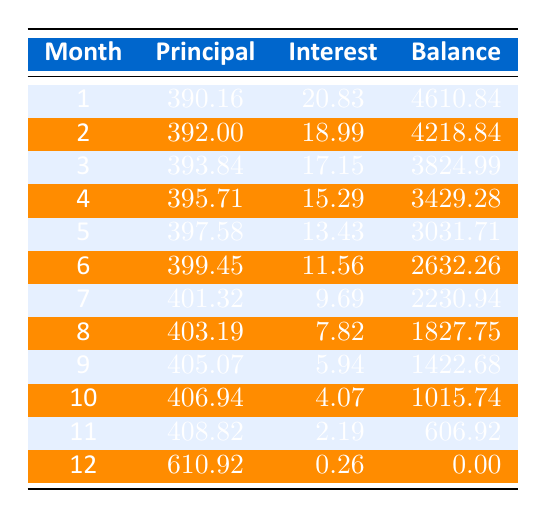What is the total loan amount? The total loan amount is specified at the beginning of the schedule as 5000.
Answer: 5000 How much was the monthly payment? The monthly payment is given in the table as 427.16.
Answer: 427.16 In which month did I pay the least interest? The interest payments are listed for each month. The lowest interest payment is 0.26, which occurs in month 12.
Answer: Month 12 What is the principal payment in month 5? The principal payment for month 5 is specifically stated in the schedule as 397.58.
Answer: 397.58 How much total principal did I pay by month 6? Adding the principal payments from months 1 to 6 gives: 390.16 + 392.00 + 393.84 + 395.71 + 397.58 + 399.45 = 2268.74.
Answer: 2268.74 Is the remaining balance after month 3 less than 4000? The remaining balance after month 3 is noted as 3824.99, which is less than 4000.
Answer: Yes How much was paid towards the principal in month 9 compared to month 1? In month 9, the principal payment is 405.07, which is 405.07 - 390.16 = 14.91 more than the principal payment in month 1.
Answer: 14.91 What is the average principal payment over the 12 months? The total principal paid over the 12 months is the sum of the principal payments: 390.16 + 392.00 + 393.84 + 395.71 + 397.58 + 399.45 + 401.32 + 403.19 + 405.07 + 406.94 + 408.82 + 610.92 = 4,814.00. Dividing this by 12 gives an average of 400.00.
Answer: 400.00 If I were to look at just the last three months' principal payments, what is the total? The principal payments for the last three months are 408.82 (month 11) + 610.92 (month 12) and month 10 = 406.94. Adding these gives: 408.82 + 406.94 + 610.92 = 1426.68.
Answer: 1426.68 